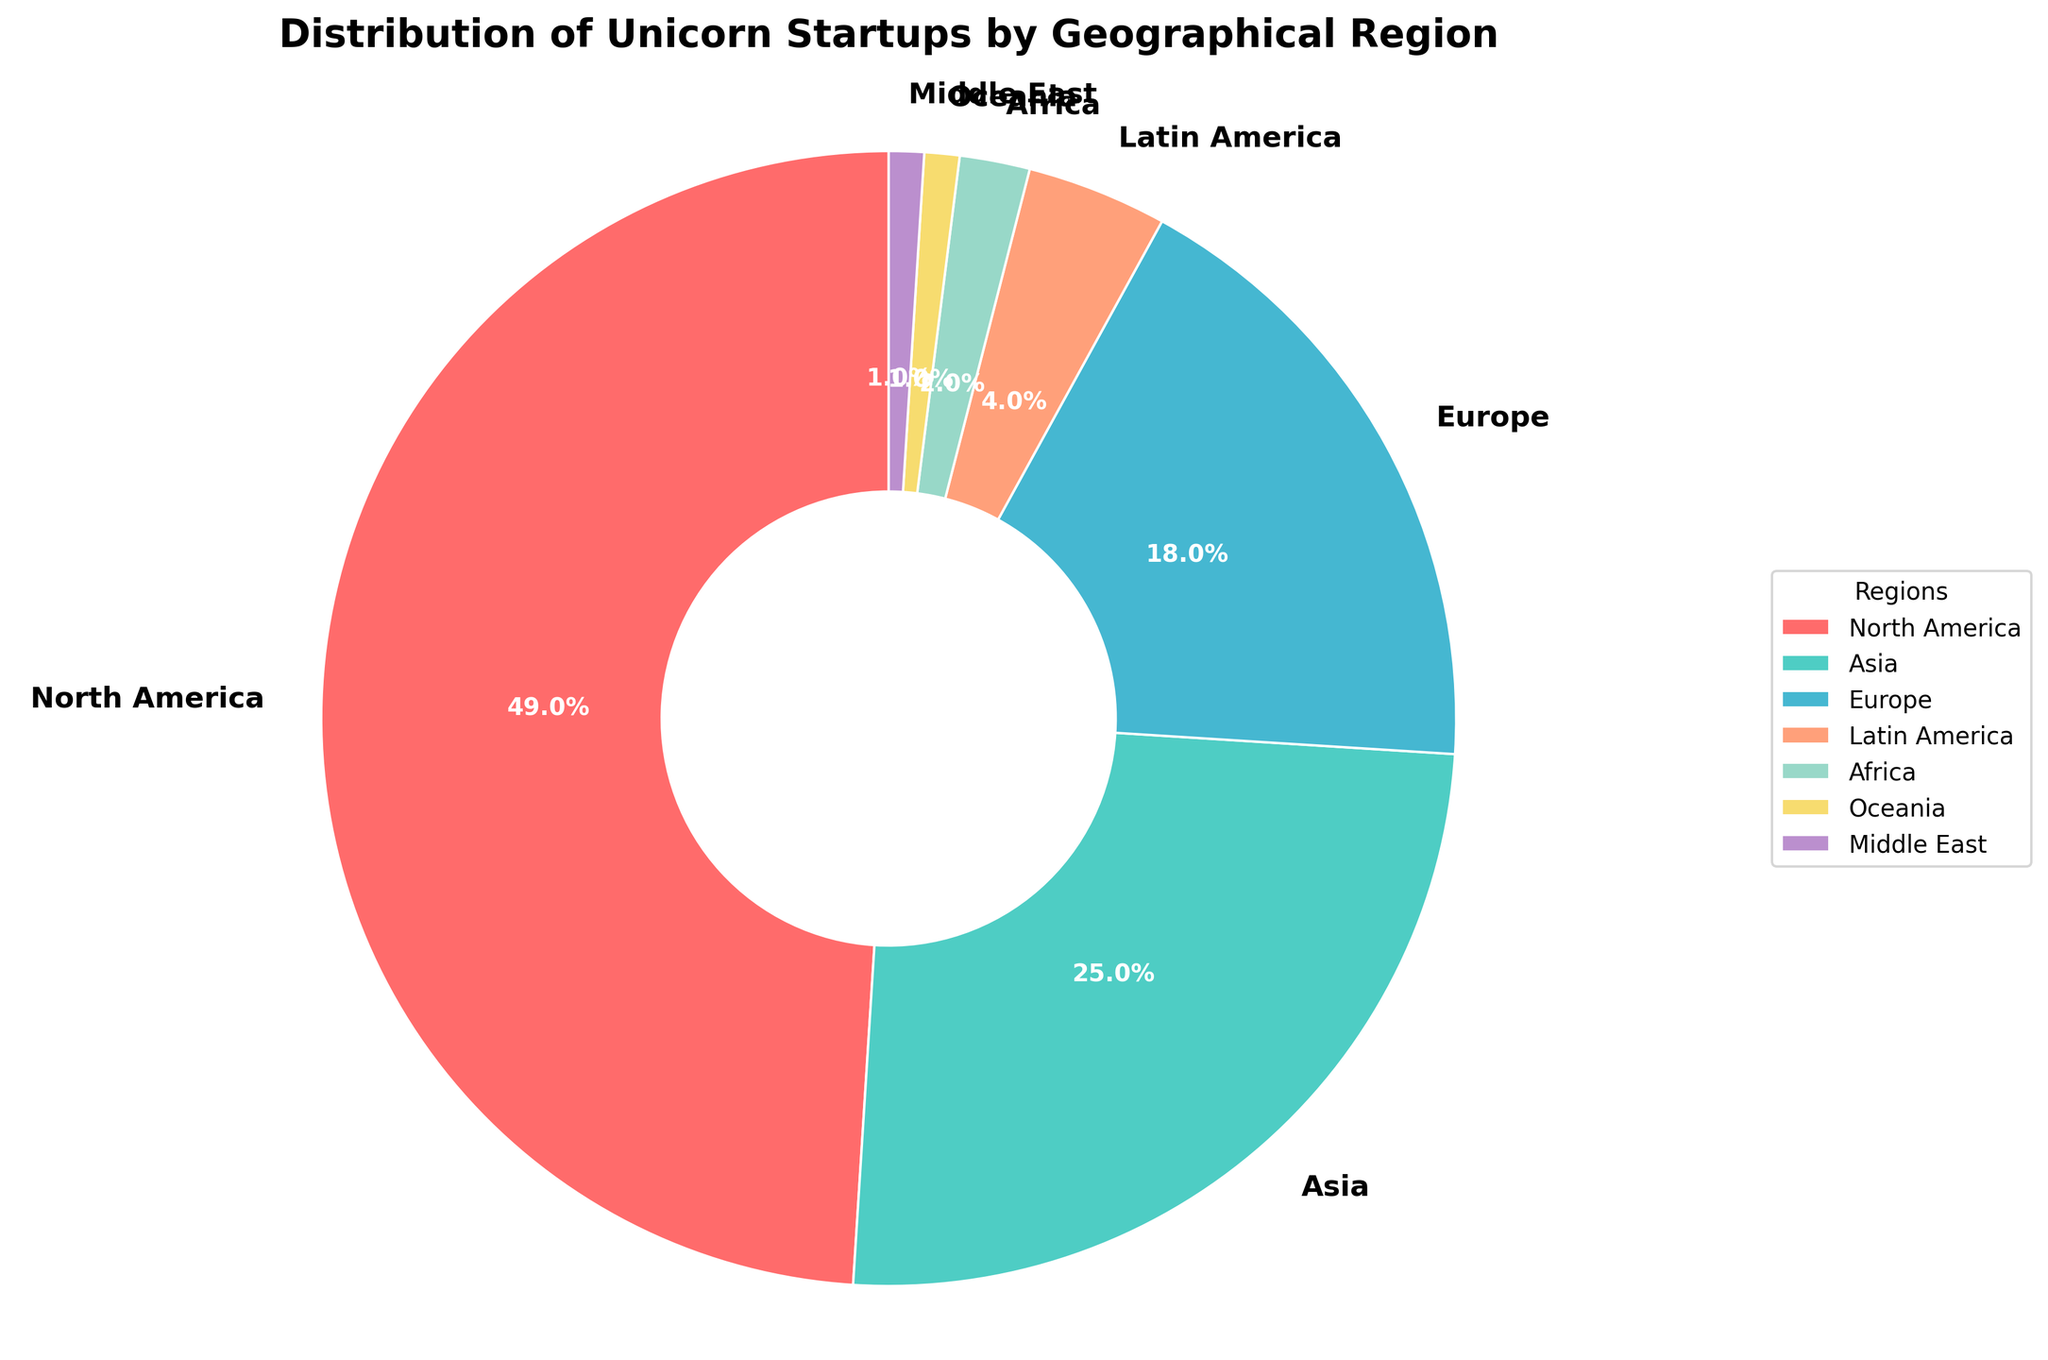Which region has the highest percentage of unicorn startups? North America has the highest percentage at 49%. This can be seen as the largest sector in the pie chart.
Answer: North America What is the combined percentage of unicorn startups in Europe and Asia? Adding the percentages of Europe (18%) and Asia (25%) gives 43%.
Answer: 43% How many regions have a share of unicorn startups greater than 10%? North America (49%), Asia (25%), and Europe (18%) each have shares greater than 10%. Counting these three regions gives us the answer.
Answer: 3 Which region has the smallest share of unicorn startups? Oceania and the Middle East each have the smallest share at 1%.
Answer: Oceania and Middle East Is the percentage of unicorn startups in North America more than double that of Europe? North America has 49% while Europe has 18%. Doubling Europe's percentage gives 36%, which is less than North America's 49%. Thus, North America's percentage is indeed more than double that of Europe's.
Answer: Yes What percentage of unicorn startups are in regions other than North America? Subtracting North America’s share from 100 gives us the percentage for other regions: 100% - 49% = 51%.
Answer: 51% Which regions have shares of unicorn startups combined that are equal to or less than 5%? Latin America (4%), Africa (2%), Oceania (1%), and the Middle East (1%) all have percentages that are 5% or less when combined.
Answer: Latin America, Africa, Oceania, Middle East What is the percentage difference between the shares of unicorn startups in Asia and Latin America? Subtracting the percentage of Latin America (4%) from Asia (25%) gives a difference of 21%.
Answer: 21% If you combine the shares of Latin America, Africa, Oceania, and the Middle East, what is the resulting percentage? Adding the percentages of Latin America (4%), Africa (2%), Oceania (1%), and the Middle East (1%) results in 4% + 2% + 1% + 1% = 8%.
Answer: 8% Compared to Europe, how much larger is North America's percentage share of unicorn startups? Subtracting Europe's percentage (18%) from North America's percentage (49%) results in 31%.
Answer: 31% 